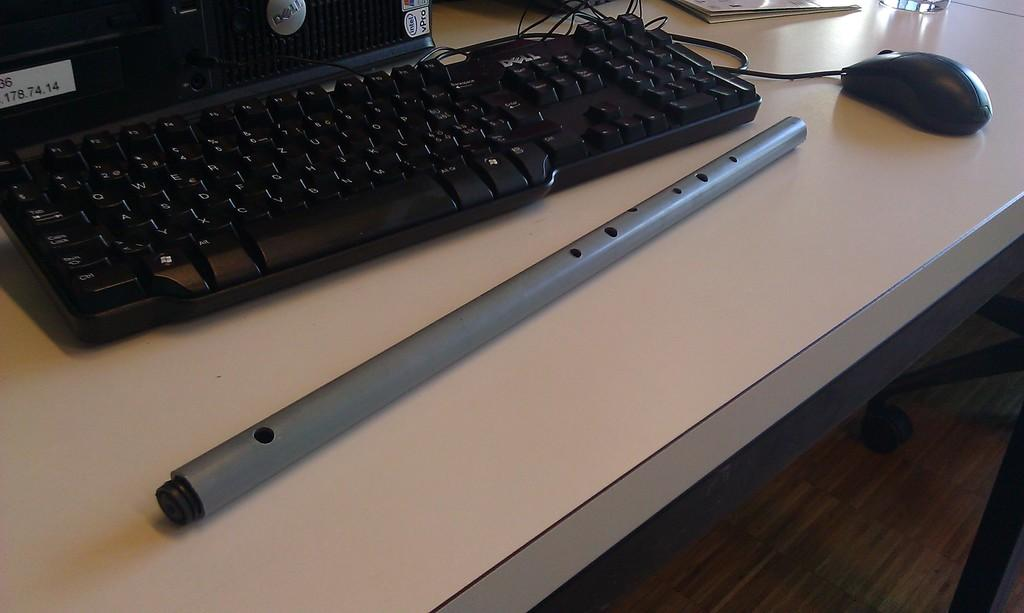What type of input device is visible in the image? There is a keyboard and a mouse in the image. What musical instrument is present in the image? There is a flute in the image. What type of electronic device is in the image? There is an electronic device in the image. What can be used for writing or documentation in the image? There are papers in the image. What is the color of the surface the objects are placed on? The surface the objects are on is cream-colored. What type of grass is growing on the keyboard in the image? There is no grass present in the image; the objects are placed on a cream-colored surface. How many cast members are visible in the image? There are no cast members present in the image; it features a keyboard, a mouse, a flute, an electronic device, papers, and a cream-colored surface. 